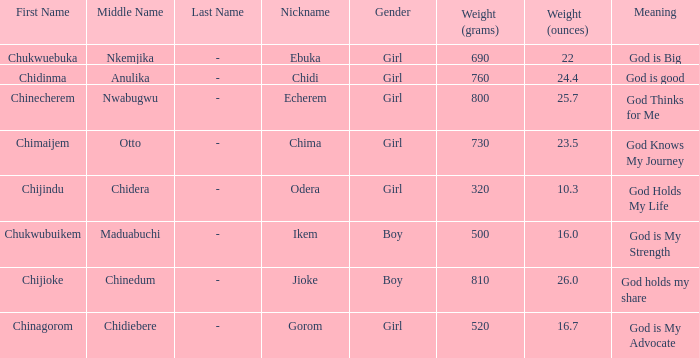How much did the girl, nicknamed Chidi, weigh at birth? 760g (24.4 oz.). 